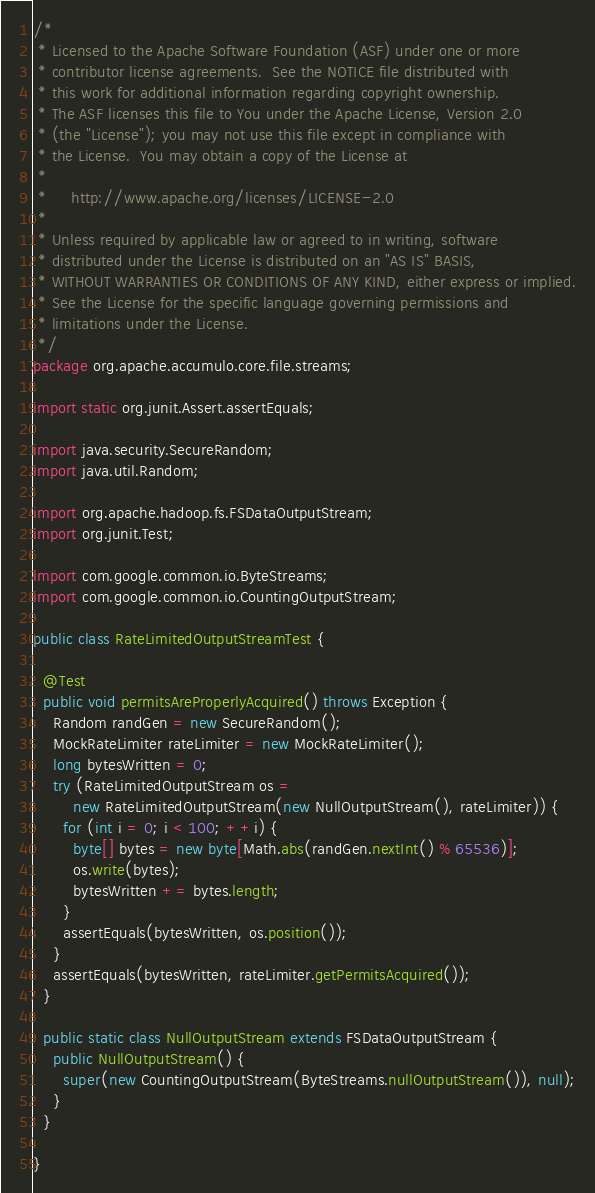<code> <loc_0><loc_0><loc_500><loc_500><_Java_>/*
 * Licensed to the Apache Software Foundation (ASF) under one or more
 * contributor license agreements.  See the NOTICE file distributed with
 * this work for additional information regarding copyright ownership.
 * The ASF licenses this file to You under the Apache License, Version 2.0
 * (the "License"); you may not use this file except in compliance with
 * the License.  You may obtain a copy of the License at
 *
 *     http://www.apache.org/licenses/LICENSE-2.0
 *
 * Unless required by applicable law or agreed to in writing, software
 * distributed under the License is distributed on an "AS IS" BASIS,
 * WITHOUT WARRANTIES OR CONDITIONS OF ANY KIND, either express or implied.
 * See the License for the specific language governing permissions and
 * limitations under the License.
 */
package org.apache.accumulo.core.file.streams;

import static org.junit.Assert.assertEquals;

import java.security.SecureRandom;
import java.util.Random;

import org.apache.hadoop.fs.FSDataOutputStream;
import org.junit.Test;

import com.google.common.io.ByteStreams;
import com.google.common.io.CountingOutputStream;

public class RateLimitedOutputStreamTest {

  @Test
  public void permitsAreProperlyAcquired() throws Exception {
    Random randGen = new SecureRandom();
    MockRateLimiter rateLimiter = new MockRateLimiter();
    long bytesWritten = 0;
    try (RateLimitedOutputStream os =
        new RateLimitedOutputStream(new NullOutputStream(), rateLimiter)) {
      for (int i = 0; i < 100; ++i) {
        byte[] bytes = new byte[Math.abs(randGen.nextInt() % 65536)];
        os.write(bytes);
        bytesWritten += bytes.length;
      }
      assertEquals(bytesWritten, os.position());
    }
    assertEquals(bytesWritten, rateLimiter.getPermitsAcquired());
  }

  public static class NullOutputStream extends FSDataOutputStream {
    public NullOutputStream() {
      super(new CountingOutputStream(ByteStreams.nullOutputStream()), null);
    }
  }

}
</code> 